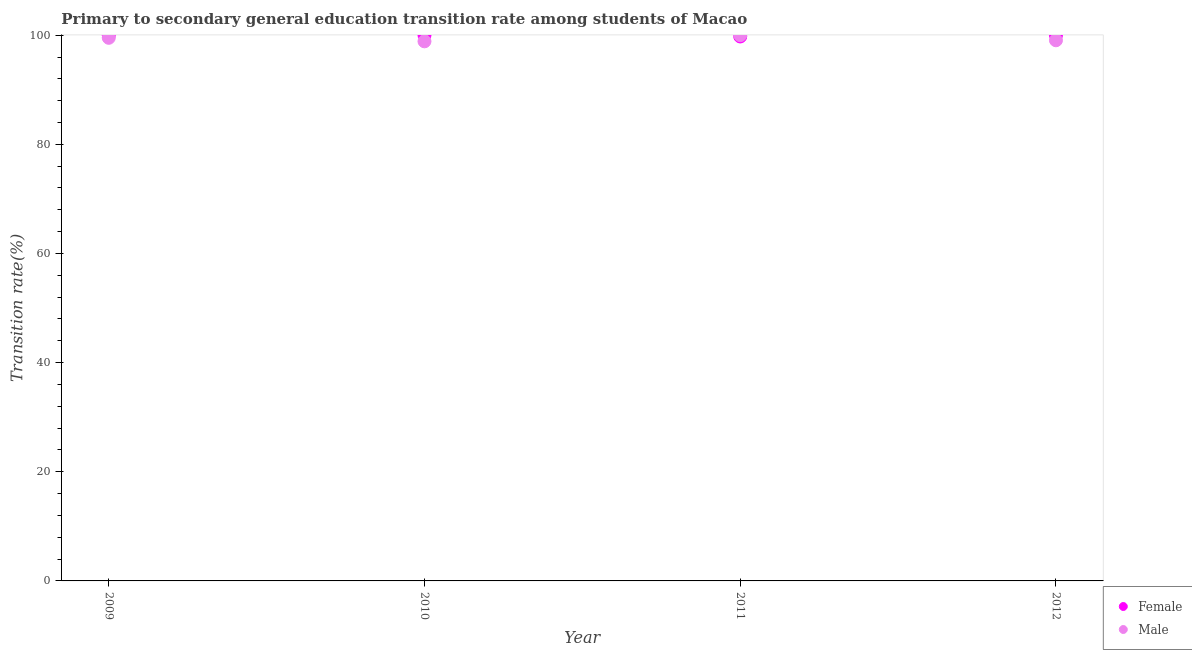Is the number of dotlines equal to the number of legend labels?
Offer a very short reply. Yes. Across all years, what is the maximum transition rate among female students?
Your answer should be compact. 100. Across all years, what is the minimum transition rate among female students?
Offer a terse response. 99.76. In which year was the transition rate among male students minimum?
Provide a succinct answer. 2010. What is the total transition rate among male students in the graph?
Your answer should be very brief. 397.46. What is the difference between the transition rate among male students in 2010 and that in 2012?
Make the answer very short. -0.19. What is the difference between the transition rate among male students in 2010 and the transition rate among female students in 2009?
Keep it short and to the point. -1.12. What is the average transition rate among female students per year?
Make the answer very short. 99.94. In the year 2010, what is the difference between the transition rate among female students and transition rate among male students?
Make the answer very short. 1.12. In how many years, is the transition rate among female students greater than 72 %?
Ensure brevity in your answer.  4. What is the ratio of the transition rate among male students in 2009 to that in 2010?
Provide a succinct answer. 1.01. Is the transition rate among female students in 2009 less than that in 2010?
Offer a terse response. No. What is the difference between the highest and the lowest transition rate among female students?
Offer a terse response. 0.24. Is the sum of the transition rate among female students in 2011 and 2012 greater than the maximum transition rate among male students across all years?
Keep it short and to the point. Yes. Does the transition rate among female students monotonically increase over the years?
Offer a terse response. No. Is the transition rate among male students strictly greater than the transition rate among female students over the years?
Ensure brevity in your answer.  No. Is the transition rate among male students strictly less than the transition rate among female students over the years?
Provide a succinct answer. No. How many dotlines are there?
Provide a succinct answer. 2. How many years are there in the graph?
Provide a short and direct response. 4. Does the graph contain grids?
Offer a terse response. No. Where does the legend appear in the graph?
Your answer should be compact. Bottom right. How many legend labels are there?
Make the answer very short. 2. How are the legend labels stacked?
Provide a short and direct response. Vertical. What is the title of the graph?
Provide a succinct answer. Primary to secondary general education transition rate among students of Macao. What is the label or title of the X-axis?
Provide a short and direct response. Year. What is the label or title of the Y-axis?
Your response must be concise. Transition rate(%). What is the Transition rate(%) in Male in 2009?
Offer a very short reply. 99.52. What is the Transition rate(%) of Female in 2010?
Ensure brevity in your answer.  100. What is the Transition rate(%) of Male in 2010?
Your answer should be compact. 98.88. What is the Transition rate(%) of Female in 2011?
Offer a terse response. 99.76. What is the Transition rate(%) of Male in 2011?
Offer a terse response. 100. What is the Transition rate(%) of Female in 2012?
Your answer should be very brief. 100. What is the Transition rate(%) in Male in 2012?
Provide a succinct answer. 99.07. Across all years, what is the maximum Transition rate(%) of Male?
Provide a short and direct response. 100. Across all years, what is the minimum Transition rate(%) of Female?
Offer a very short reply. 99.76. Across all years, what is the minimum Transition rate(%) of Male?
Give a very brief answer. 98.88. What is the total Transition rate(%) of Female in the graph?
Your response must be concise. 399.76. What is the total Transition rate(%) of Male in the graph?
Offer a terse response. 397.46. What is the difference between the Transition rate(%) of Male in 2009 and that in 2010?
Provide a short and direct response. 0.64. What is the difference between the Transition rate(%) of Female in 2009 and that in 2011?
Offer a terse response. 0.24. What is the difference between the Transition rate(%) in Male in 2009 and that in 2011?
Your response must be concise. -0.48. What is the difference between the Transition rate(%) of Female in 2009 and that in 2012?
Give a very brief answer. 0. What is the difference between the Transition rate(%) in Male in 2009 and that in 2012?
Ensure brevity in your answer.  0.45. What is the difference between the Transition rate(%) of Female in 2010 and that in 2011?
Offer a terse response. 0.24. What is the difference between the Transition rate(%) of Male in 2010 and that in 2011?
Keep it short and to the point. -1.12. What is the difference between the Transition rate(%) in Male in 2010 and that in 2012?
Give a very brief answer. -0.19. What is the difference between the Transition rate(%) in Female in 2011 and that in 2012?
Your answer should be compact. -0.24. What is the difference between the Transition rate(%) in Male in 2011 and that in 2012?
Give a very brief answer. 0.93. What is the difference between the Transition rate(%) in Female in 2009 and the Transition rate(%) in Male in 2010?
Your answer should be very brief. 1.12. What is the difference between the Transition rate(%) of Female in 2009 and the Transition rate(%) of Male in 2012?
Your response must be concise. 0.93. What is the difference between the Transition rate(%) of Female in 2010 and the Transition rate(%) of Male in 2012?
Your response must be concise. 0.93. What is the difference between the Transition rate(%) in Female in 2011 and the Transition rate(%) in Male in 2012?
Provide a short and direct response. 0.7. What is the average Transition rate(%) of Female per year?
Make the answer very short. 99.94. What is the average Transition rate(%) in Male per year?
Offer a terse response. 99.37. In the year 2009, what is the difference between the Transition rate(%) in Female and Transition rate(%) in Male?
Provide a short and direct response. 0.48. In the year 2010, what is the difference between the Transition rate(%) in Female and Transition rate(%) in Male?
Make the answer very short. 1.12. In the year 2011, what is the difference between the Transition rate(%) of Female and Transition rate(%) of Male?
Make the answer very short. -0.24. In the year 2012, what is the difference between the Transition rate(%) of Female and Transition rate(%) of Male?
Your response must be concise. 0.93. What is the ratio of the Transition rate(%) in Female in 2009 to that in 2010?
Make the answer very short. 1. What is the ratio of the Transition rate(%) in Male in 2009 to that in 2010?
Give a very brief answer. 1.01. What is the ratio of the Transition rate(%) in Female in 2009 to that in 2011?
Ensure brevity in your answer.  1. What is the ratio of the Transition rate(%) of Male in 2009 to that in 2011?
Offer a very short reply. 1. What is the ratio of the Transition rate(%) in Female in 2009 to that in 2012?
Provide a short and direct response. 1. What is the ratio of the Transition rate(%) in Male in 2010 to that in 2011?
Offer a terse response. 0.99. What is the ratio of the Transition rate(%) in Female in 2010 to that in 2012?
Keep it short and to the point. 1. What is the ratio of the Transition rate(%) of Female in 2011 to that in 2012?
Your response must be concise. 1. What is the ratio of the Transition rate(%) in Male in 2011 to that in 2012?
Provide a short and direct response. 1.01. What is the difference between the highest and the second highest Transition rate(%) in Female?
Offer a very short reply. 0. What is the difference between the highest and the second highest Transition rate(%) in Male?
Provide a short and direct response. 0.48. What is the difference between the highest and the lowest Transition rate(%) of Female?
Provide a succinct answer. 0.24. What is the difference between the highest and the lowest Transition rate(%) of Male?
Your response must be concise. 1.12. 